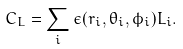Convert formula to latex. <formula><loc_0><loc_0><loc_500><loc_500>C _ { L } = \sum _ { i } \epsilon ( r _ { i } , \theta _ { i } , \phi _ { i } ) L _ { i } .</formula> 